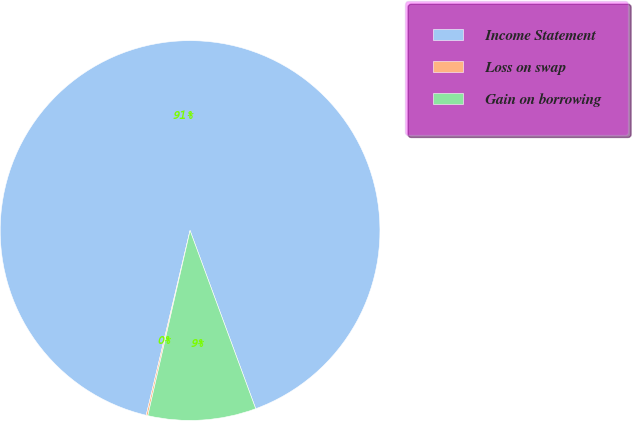Convert chart. <chart><loc_0><loc_0><loc_500><loc_500><pie_chart><fcel>Income Statement<fcel>Loss on swap<fcel>Gain on borrowing<nl><fcel>90.68%<fcel>0.14%<fcel>9.19%<nl></chart> 